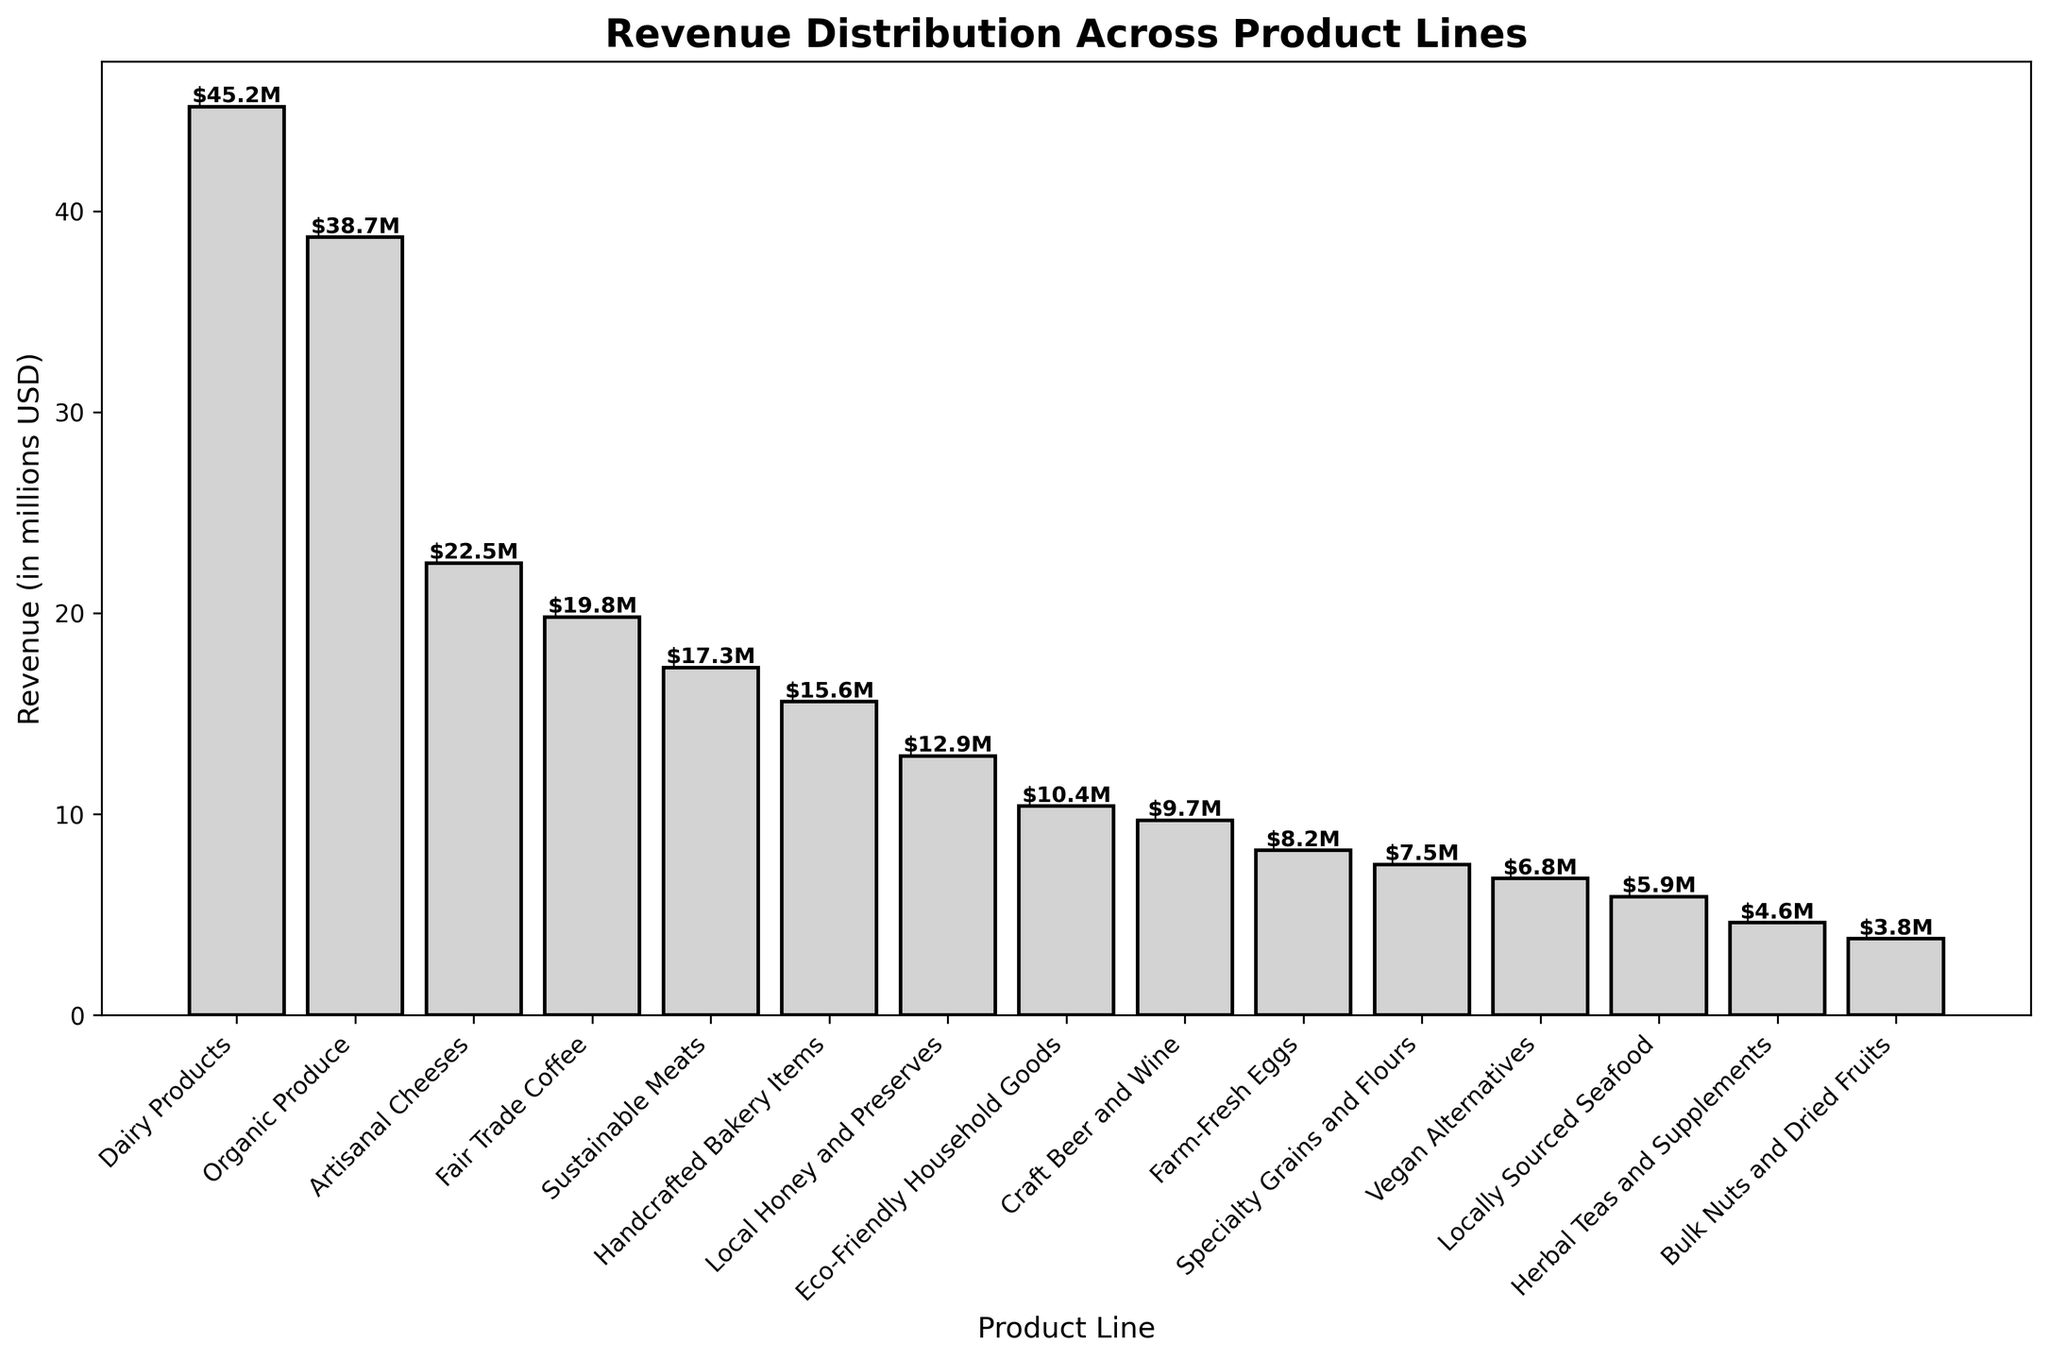What's the total revenue of the top three product lines? Add the revenues of the top three product lines: Dairy Products ($45.2M), Organic Produce ($38.7M), and Artisanal Cheeses ($22.5M). The total revenue is $45.2M + $38.7M + $22.5M = $106.4M.
Answer: $106.4M Which product line has the lowest revenue, and how much is it? Look for the product line with the shortest bar. The shortest bar corresponds to Bulk Nuts and Dried Fruits, with a revenue of $3.8M.
Answer: Bulk Nuts and Dried Fruits, $3.8M How much more revenue does Dairy Products generate compared to Fair Trade Coffee? Find the heights of the bars for Dairy Products and Fair Trade Coffee. Calculate the difference: $45.2M (Dairy Products) - $19.8M (Fair Trade Coffee) = $25.4M.
Answer: $25.4M Which product line has revenue closest to $10 million? Look for the bar where the height is closest to $10 million. Eco-Friendly Household Goods has a revenue of $10.4M, which is the closest to $10M.
Answer: Eco-Friendly Household Goods Calculate the average revenue of the bottom five product lines. Identify the bottom five product lines: Locally Sourced Seafood ($5.9M), Herbal Teas and Supplements ($4.6M), Bulk Nuts and Dried Fruits ($3.8M). Sum their revenues and divide by 5: ($5.9M + $4.6M + $3.8M) / 5 = $14.3M / 5 = $2.86M.
Answer: $2.86M Compare the revenues of Sustainable Meats and Craft Beer and Wine. Which one generates more revenue and what is the difference? Check the heights of the bars for Sustainable Meats ($17.3M) and Craft Beer and Wine ($9.7M). Sustainable Meats generates more revenue. The difference is $17.3M - $9.7M = $7.6M.
Answer: Sustainable Meats, $7.6M What is the combined revenue of Vegan Alternatives and Specialty Grains and Flours? Add the revenues of Vegan Alternatives ($6.8M) and Specialty Grains and Flours ($7.5M). The combined revenue is $6.8M + $7.5M = $14.3M.
Answer: $14.3M Which product line has a revenue closest to the median value of all listed revenues? To find the median, list all revenues and find the middle value. The sorted revenue list is: $3.8M, $4.6M, $5.9M, $6.8M, $7.5M, $8.2M, $9.7M, $10.4M, $12.9M, $15.6M, $17.3M, $19.8M, $22.5M, $38.7M, $45.2M. The median value is $10.4M, which is revenue for Eco-Friendly Household Goods.
Answer: Eco-Friendly Household Goods 